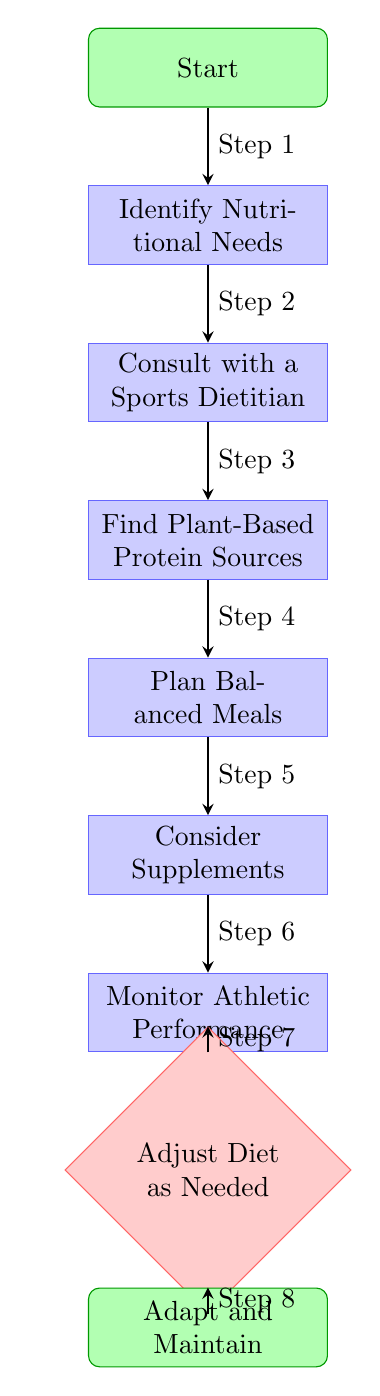What is the first step in the flow chart? The flow chart starts with the node labeled "Start," which indicates the beginning of the process.
Answer: Start How many nodes are in the diagram? The diagram contains a total of 9 nodes: "Start," "Identify Nutritional Needs," "Consult with a Sports Dietitian," "Find Plant-Based Protein Sources," "Plan Balanced Meals," "Consider Supplements," "Monitor Athletic Performance," "Adjust Diet as Needed," and "Adapt and Maintain."
Answer: 9 What is the last step in the flow chart? The flow chart ends with the node labeled "Adapt and Maintain," which signifies the conclusion of the process.
Answer: Adapt and Maintain Which node comes after "Plan Balanced Meals"? After "Plan Balanced Meals," the next node in the flow is "Consider Supplements," indicating the next action to be taken.
Answer: Consider Supplements How many steps are listed in the diagram? The diagram includes 8 steps, which are sequential actions that lead through the process of transitioning to a plant-based diet as an athlete.
Answer: 8 What node follows "Monitor Athletic Performance"? The node that follows "Monitor Athletic Performance" is "Adjust Diet as Needed," defining what to do after monitoring performance.
Answer: Adjust Diet as Needed In which step is it advised to consult a sports dietitian? Consulting with a Sports Dietitian is indicated as Step 2 in the flow chart, which follows the identification of nutritional needs.
Answer: Step 2 What step comes directly before "Adjust Diet as Needed"? The step that comes directly before "Adjust Diet as Needed" is "Monitor Athletic Performance," which is a critical action taken before any dietary adjustments are made.
Answer: Monitor Athletic Performance 